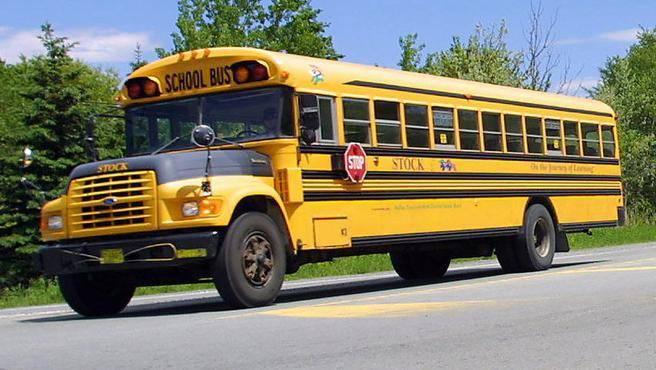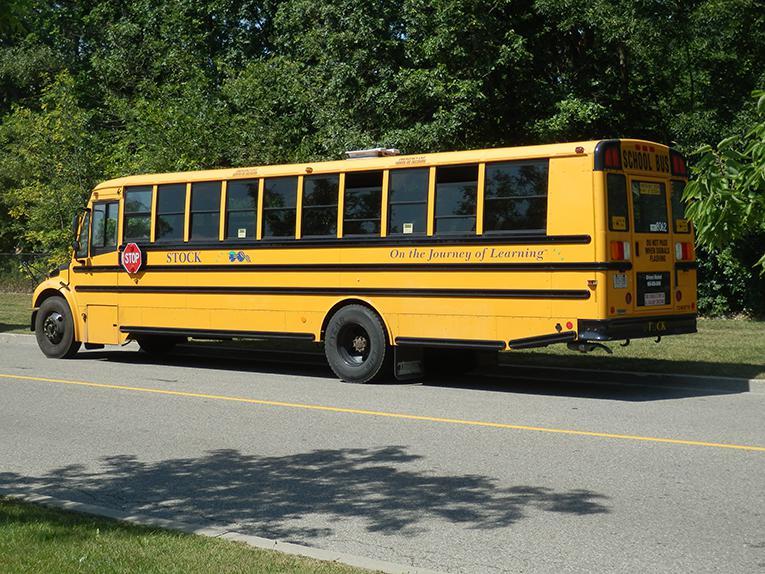The first image is the image on the left, the second image is the image on the right. Evaluate the accuracy of this statement regarding the images: "The buses in the left and right images are displayed horizontally and back-to-back.". Is it true? Answer yes or no. No. 